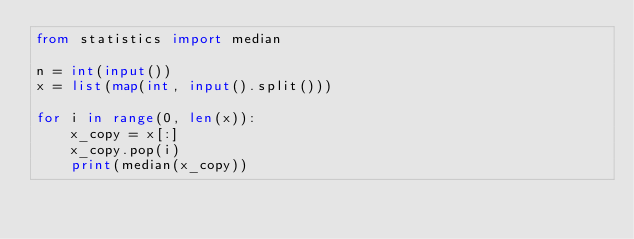Convert code to text. <code><loc_0><loc_0><loc_500><loc_500><_Python_>from statistics import median

n = int(input())
x = list(map(int, input().split()))

for i in range(0, len(x)):
    x_copy = x[:]
    x_copy.pop(i)
    print(median(x_copy))</code> 